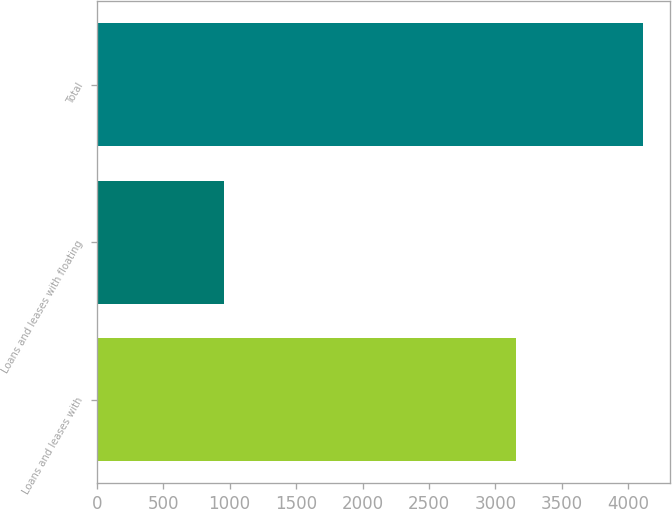Convert chart to OTSL. <chart><loc_0><loc_0><loc_500><loc_500><bar_chart><fcel>Loans and leases with<fcel>Loans and leases with floating<fcel>Total<nl><fcel>3151<fcel>958<fcel>4109<nl></chart> 